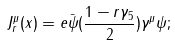Convert formula to latex. <formula><loc_0><loc_0><loc_500><loc_500>J _ { r } ^ { \mu } ( x ) = e \bar { \psi } ( { \frac { 1 - r \gamma _ { 5 } } { 2 } } ) \gamma ^ { \mu } \psi ;</formula> 